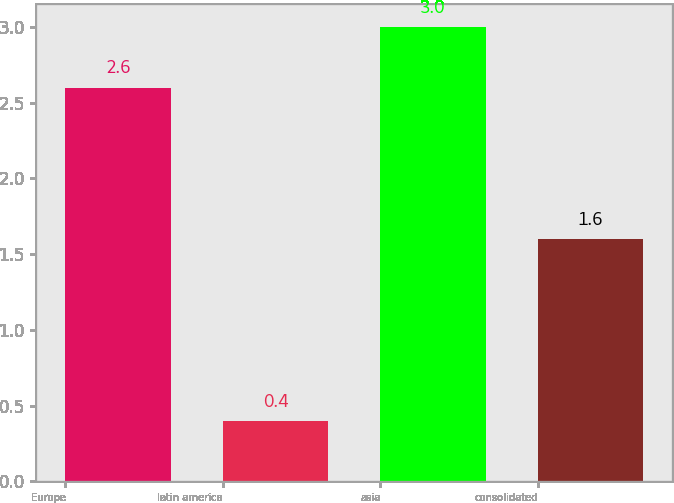Convert chart to OTSL. <chart><loc_0><loc_0><loc_500><loc_500><bar_chart><fcel>Europe<fcel>latin america<fcel>asia<fcel>consolidated<nl><fcel>2.6<fcel>0.4<fcel>3<fcel>1.6<nl></chart> 